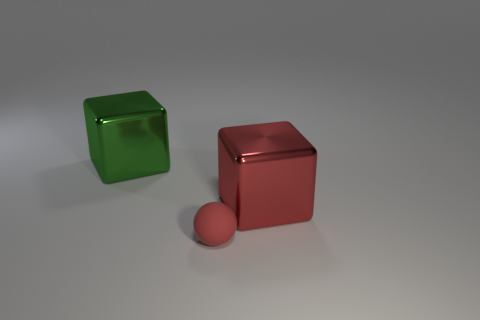What kind of mood or atmosphere does the image portray? The image has a minimalist and clean aesthetic that gives off a calm and ordered mood. The choice of cool and warm colors adds contrast while the soft lighting and gentle shadows contribute to a serene and contemplative atmosphere. 